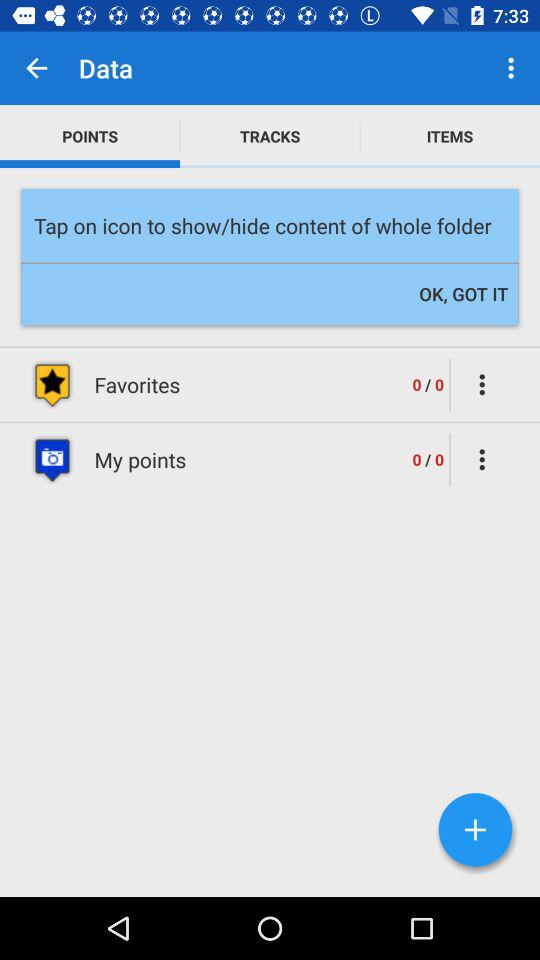What are the total points in "My points"? The total points are 0. 